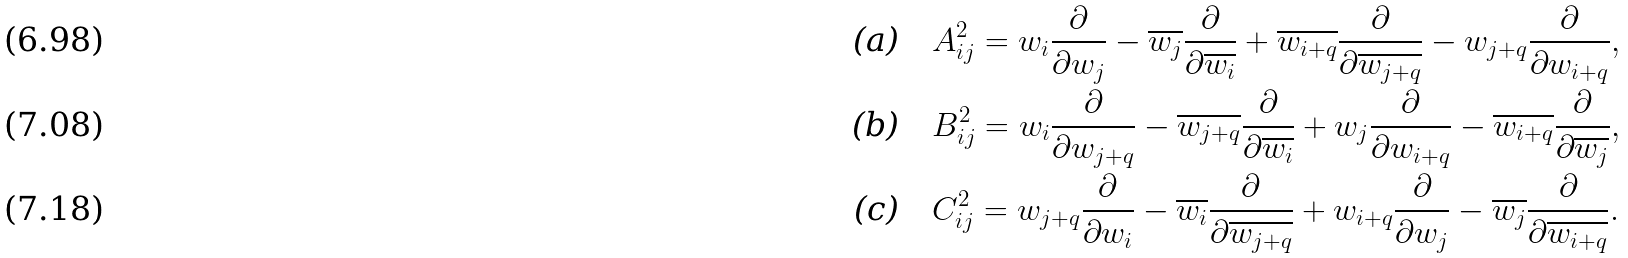Convert formula to latex. <formula><loc_0><loc_0><loc_500><loc_500>\text {(a)} \quad & A _ { i j } ^ { 2 } = w _ { i } \frac { \partial } { \partial w _ { j } } - \overline { w _ { j } } \frac { \partial } { \partial \overline { w _ { i } } } + \overline { w _ { i + q } } \frac { \partial } { \partial \overline { w _ { j + q } } } - w _ { j + q } \frac { \partial } { \partial w _ { i + q } } , \\ \text {(b)} \quad & B _ { i j } ^ { 2 } = w _ { i } \frac { \partial } { \partial w _ { j + q } } - \overline { w _ { j + q } } \frac { \partial } { \partial \overline { w _ { i } } } + w _ { j } \frac { \partial } { \partial w _ { i + q } } - \overline { w _ { i + q } } \frac { \partial } { \partial \overline { w _ { j } } } , \\ \text {(c)} \quad & C _ { i j } ^ { 2 } = w _ { j + q } \frac { \partial } { \partial w _ { i } } - \overline { w _ { i } } \frac { \partial } { \partial \overline { w _ { j + q } } } + w _ { i + q } \frac { \partial } { \partial w _ { j } } - \overline { w _ { j } } \frac { \partial } { \partial \overline { w _ { i + q } } } .</formula> 